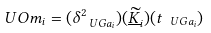Convert formula to latex. <formula><loc_0><loc_0><loc_500><loc_500>\ U O m _ { i } = ( \delta _ { \ U G a _ { i } } ^ { 2 } ) ( \underline { \widetilde { K } } _ { i } ) ( t _ { \ U G a _ { i } } )</formula> 